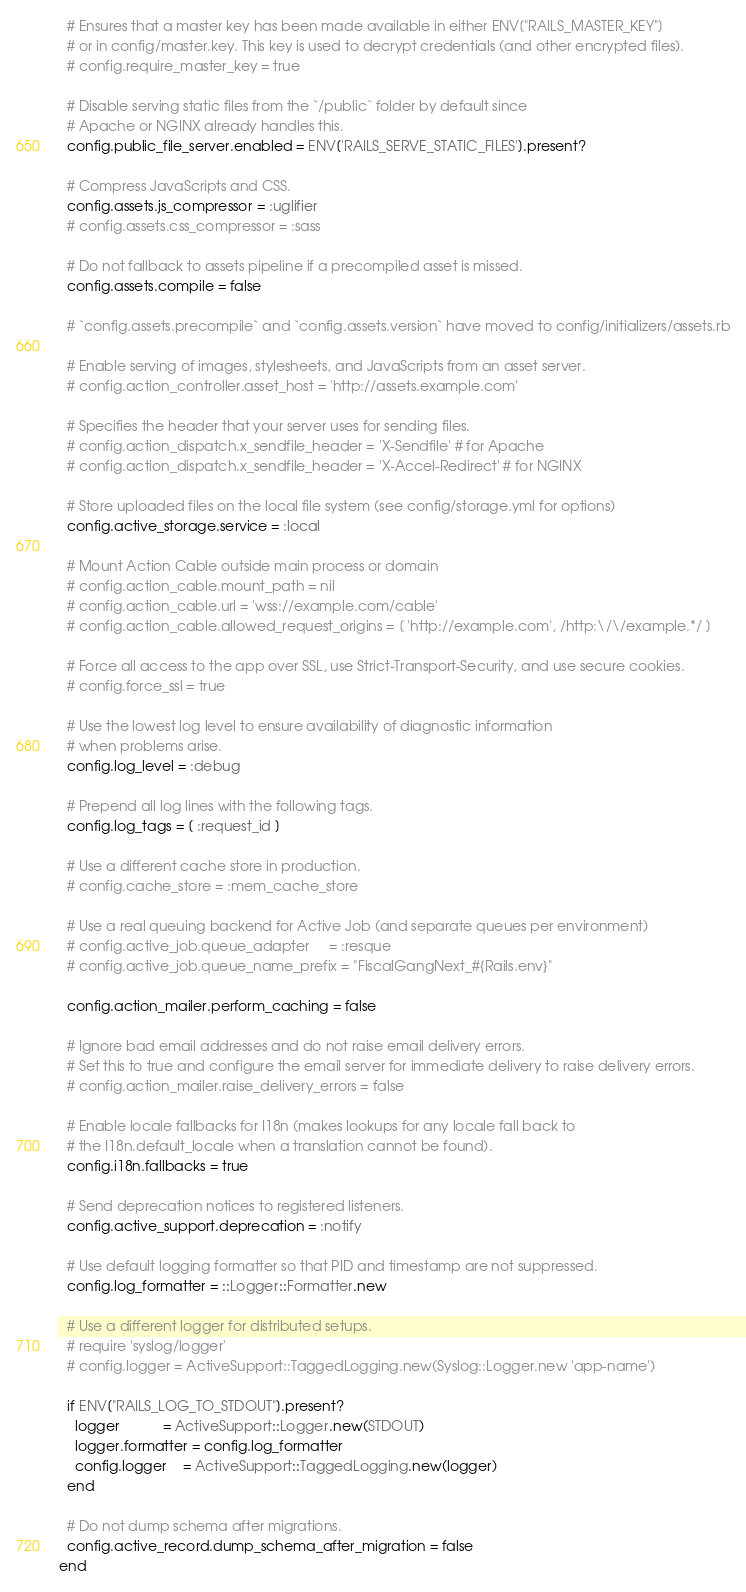Convert code to text. <code><loc_0><loc_0><loc_500><loc_500><_Ruby_>
  # Ensures that a master key has been made available in either ENV["RAILS_MASTER_KEY"]
  # or in config/master.key. This key is used to decrypt credentials (and other encrypted files).
  # config.require_master_key = true

  # Disable serving static files from the `/public` folder by default since
  # Apache or NGINX already handles this.
  config.public_file_server.enabled = ENV['RAILS_SERVE_STATIC_FILES'].present?

  # Compress JavaScripts and CSS.
  config.assets.js_compressor = :uglifier
  # config.assets.css_compressor = :sass

  # Do not fallback to assets pipeline if a precompiled asset is missed.
  config.assets.compile = false

  # `config.assets.precompile` and `config.assets.version` have moved to config/initializers/assets.rb

  # Enable serving of images, stylesheets, and JavaScripts from an asset server.
  # config.action_controller.asset_host = 'http://assets.example.com'

  # Specifies the header that your server uses for sending files.
  # config.action_dispatch.x_sendfile_header = 'X-Sendfile' # for Apache
  # config.action_dispatch.x_sendfile_header = 'X-Accel-Redirect' # for NGINX

  # Store uploaded files on the local file system (see config/storage.yml for options)
  config.active_storage.service = :local

  # Mount Action Cable outside main process or domain
  # config.action_cable.mount_path = nil
  # config.action_cable.url = 'wss://example.com/cable'
  # config.action_cable.allowed_request_origins = [ 'http://example.com', /http:\/\/example.*/ ]

  # Force all access to the app over SSL, use Strict-Transport-Security, and use secure cookies.
  # config.force_ssl = true

  # Use the lowest log level to ensure availability of diagnostic information
  # when problems arise.
  config.log_level = :debug

  # Prepend all log lines with the following tags.
  config.log_tags = [ :request_id ]

  # Use a different cache store in production.
  # config.cache_store = :mem_cache_store

  # Use a real queuing backend for Active Job (and separate queues per environment)
  # config.active_job.queue_adapter     = :resque
  # config.active_job.queue_name_prefix = "FiscalGangNext_#{Rails.env}"

  config.action_mailer.perform_caching = false

  # Ignore bad email addresses and do not raise email delivery errors.
  # Set this to true and configure the email server for immediate delivery to raise delivery errors.
  # config.action_mailer.raise_delivery_errors = false

  # Enable locale fallbacks for I18n (makes lookups for any locale fall back to
  # the I18n.default_locale when a translation cannot be found).
  config.i18n.fallbacks = true

  # Send deprecation notices to registered listeners.
  config.active_support.deprecation = :notify

  # Use default logging formatter so that PID and timestamp are not suppressed.
  config.log_formatter = ::Logger::Formatter.new

  # Use a different logger for distributed setups.
  # require 'syslog/logger'
  # config.logger = ActiveSupport::TaggedLogging.new(Syslog::Logger.new 'app-name')

  if ENV["RAILS_LOG_TO_STDOUT"].present?
    logger           = ActiveSupport::Logger.new(STDOUT)
    logger.formatter = config.log_formatter
    config.logger    = ActiveSupport::TaggedLogging.new(logger)
  end

  # Do not dump schema after migrations.
  config.active_record.dump_schema_after_migration = false
end
</code> 